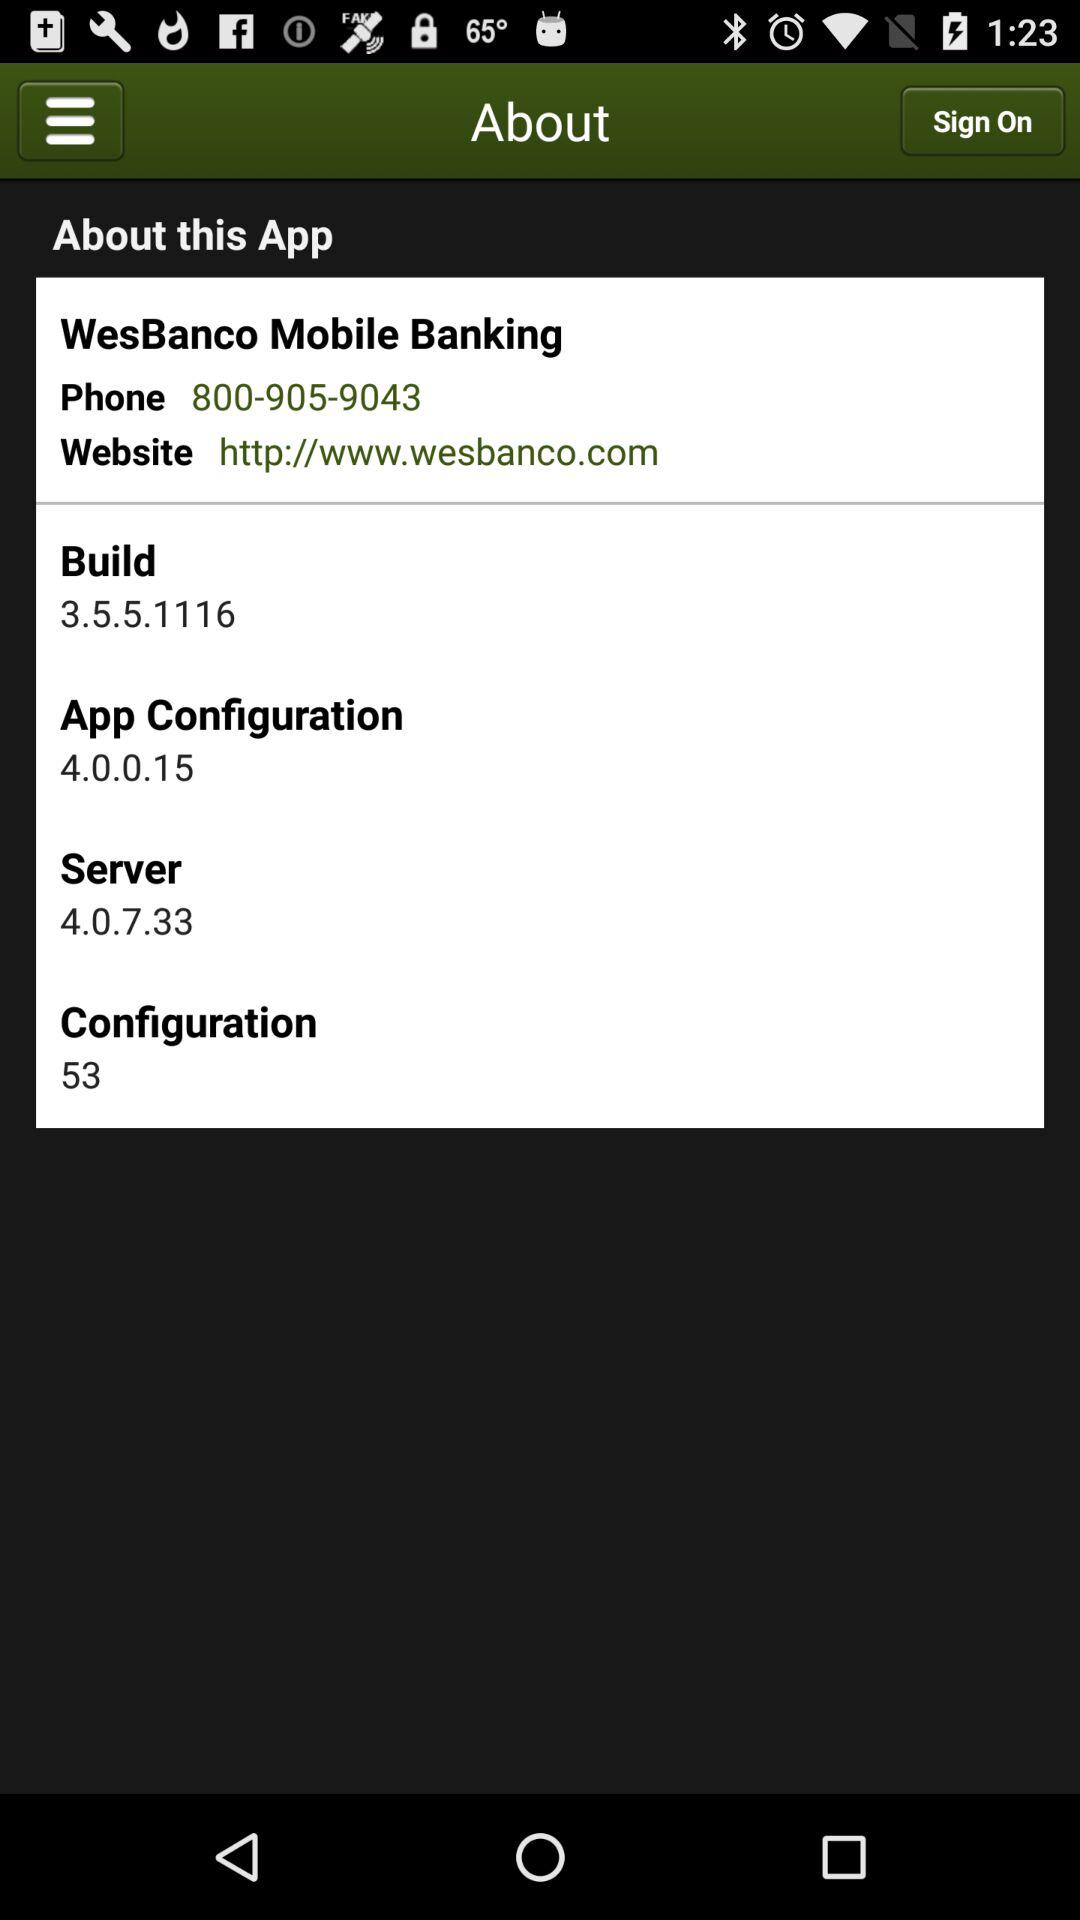What is the phone number? The phone number is 800-905-9043. 